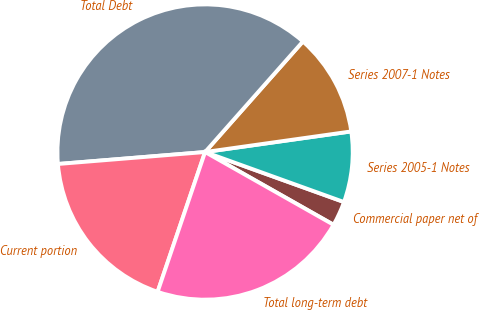Convert chart. <chart><loc_0><loc_0><loc_500><loc_500><pie_chart><fcel>Commercial paper net of<fcel>Series 2005-1 Notes<fcel>Series 2007-1 Notes<fcel>Total Debt<fcel>Current portion<fcel>Total long-term debt<nl><fcel>2.7%<fcel>7.73%<fcel>11.24%<fcel>37.82%<fcel>18.5%<fcel>22.01%<nl></chart> 